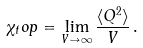Convert formula to latex. <formula><loc_0><loc_0><loc_500><loc_500>\chi _ { t } o p = \lim _ { V \to \infty } \frac { \langle Q ^ { 2 } \rangle } { V } \, .</formula> 